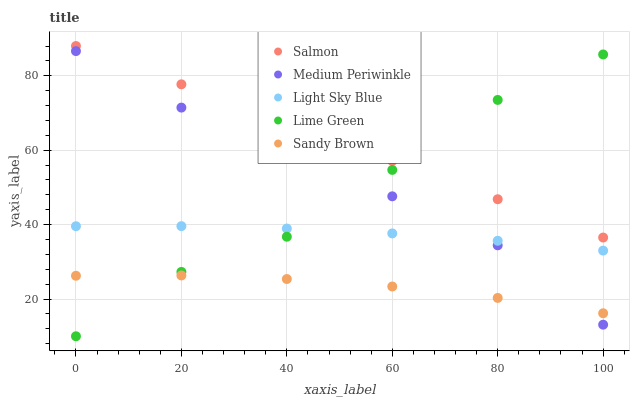Does Sandy Brown have the minimum area under the curve?
Answer yes or no. Yes. Does Salmon have the maximum area under the curve?
Answer yes or no. Yes. Does Light Sky Blue have the minimum area under the curve?
Answer yes or no. No. Does Light Sky Blue have the maximum area under the curve?
Answer yes or no. No. Is Salmon the smoothest?
Answer yes or no. Yes. Is Lime Green the roughest?
Answer yes or no. Yes. Is Light Sky Blue the smoothest?
Answer yes or no. No. Is Light Sky Blue the roughest?
Answer yes or no. No. Does Lime Green have the lowest value?
Answer yes or no. Yes. Does Light Sky Blue have the lowest value?
Answer yes or no. No. Does Salmon have the highest value?
Answer yes or no. Yes. Does Light Sky Blue have the highest value?
Answer yes or no. No. Is Sandy Brown less than Salmon?
Answer yes or no. Yes. Is Light Sky Blue greater than Sandy Brown?
Answer yes or no. Yes. Does Lime Green intersect Sandy Brown?
Answer yes or no. Yes. Is Lime Green less than Sandy Brown?
Answer yes or no. No. Is Lime Green greater than Sandy Brown?
Answer yes or no. No. Does Sandy Brown intersect Salmon?
Answer yes or no. No. 